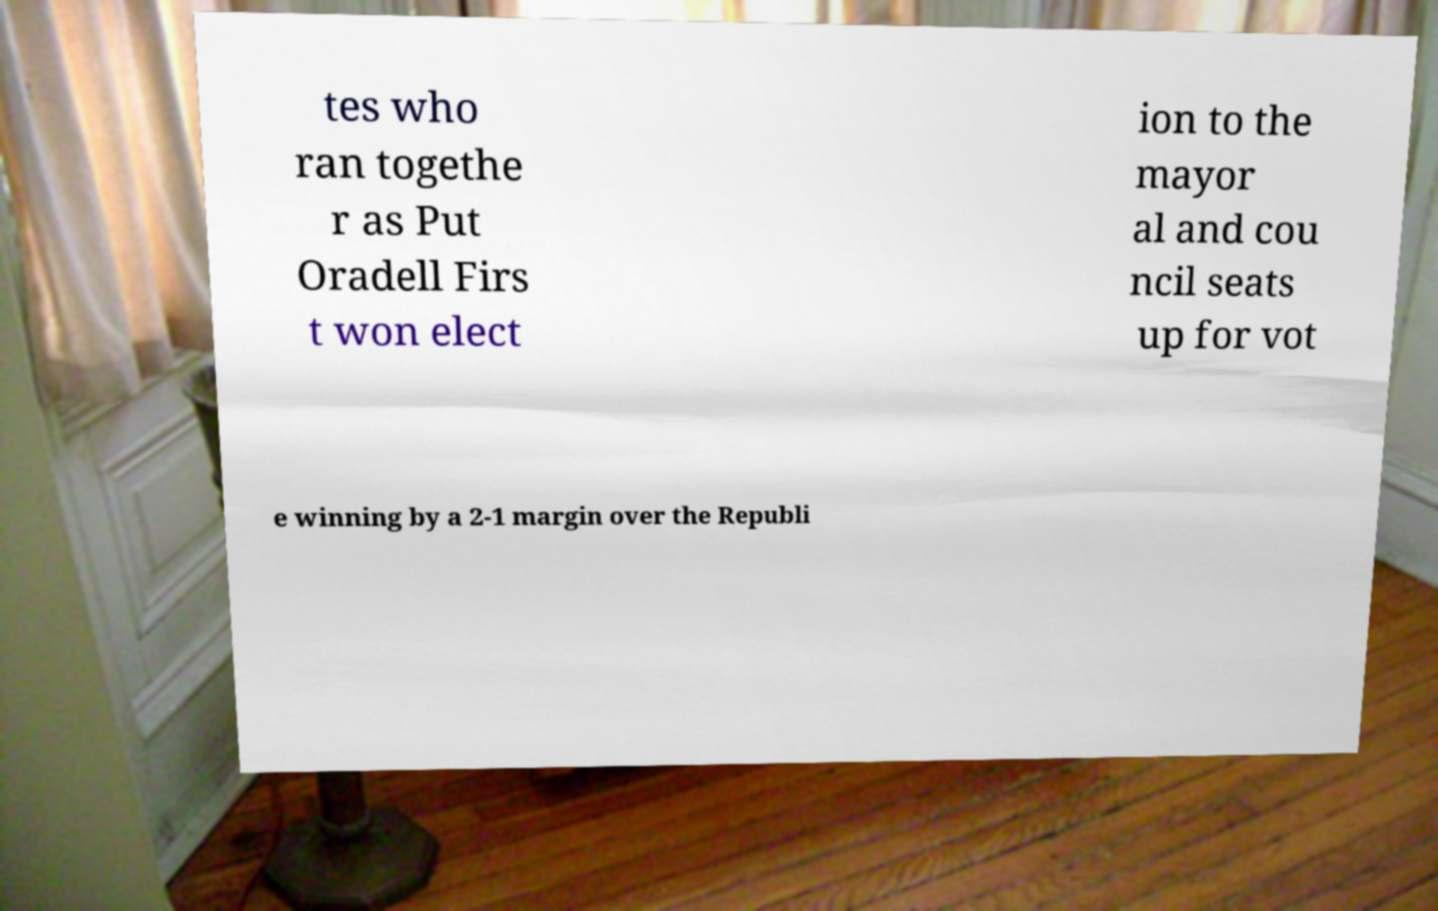Please identify and transcribe the text found in this image. tes who ran togethe r as Put Oradell Firs t won elect ion to the mayor al and cou ncil seats up for vot e winning by a 2-1 margin over the Republi 